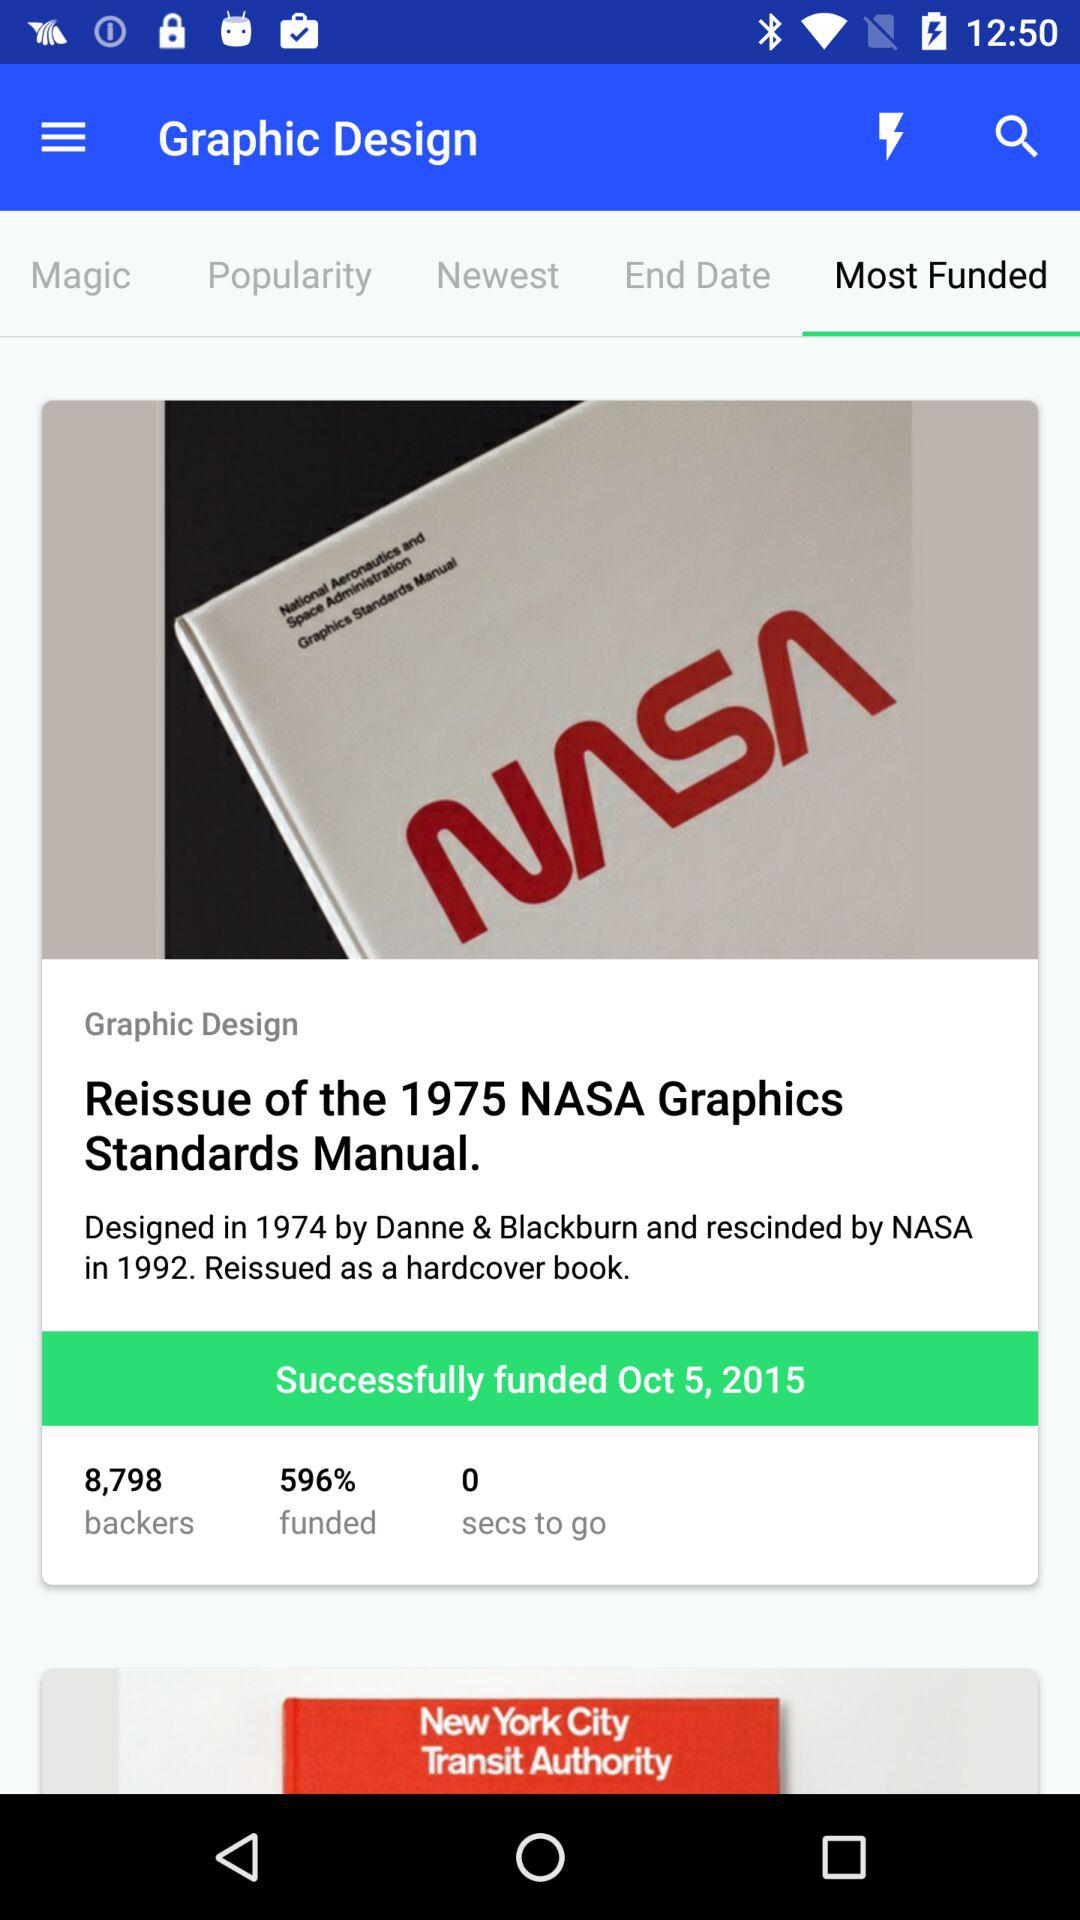What is the percentage of funds mentioned? The percentage is 596. 